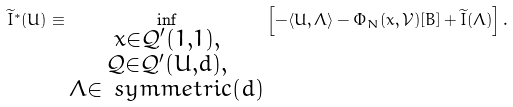<formula> <loc_0><loc_0><loc_500><loc_500>\widetilde { I } ^ { * } ( U ) \equiv \inf _ { \substack { x \in \mathcal { Q } ^ { \prime } ( 1 , 1 ) , \\ \mathcal { Q } \in \mathcal { Q } ^ { \prime } ( U , d ) , \\ \Lambda \in \ s y m m e t r i c ( d ) } } \left [ - \langle U , \Lambda \rangle - \Phi _ { N } ( x , \mathcal { V } ) [ B ] + \widetilde { I } ( \Lambda ) \right ] .</formula> 